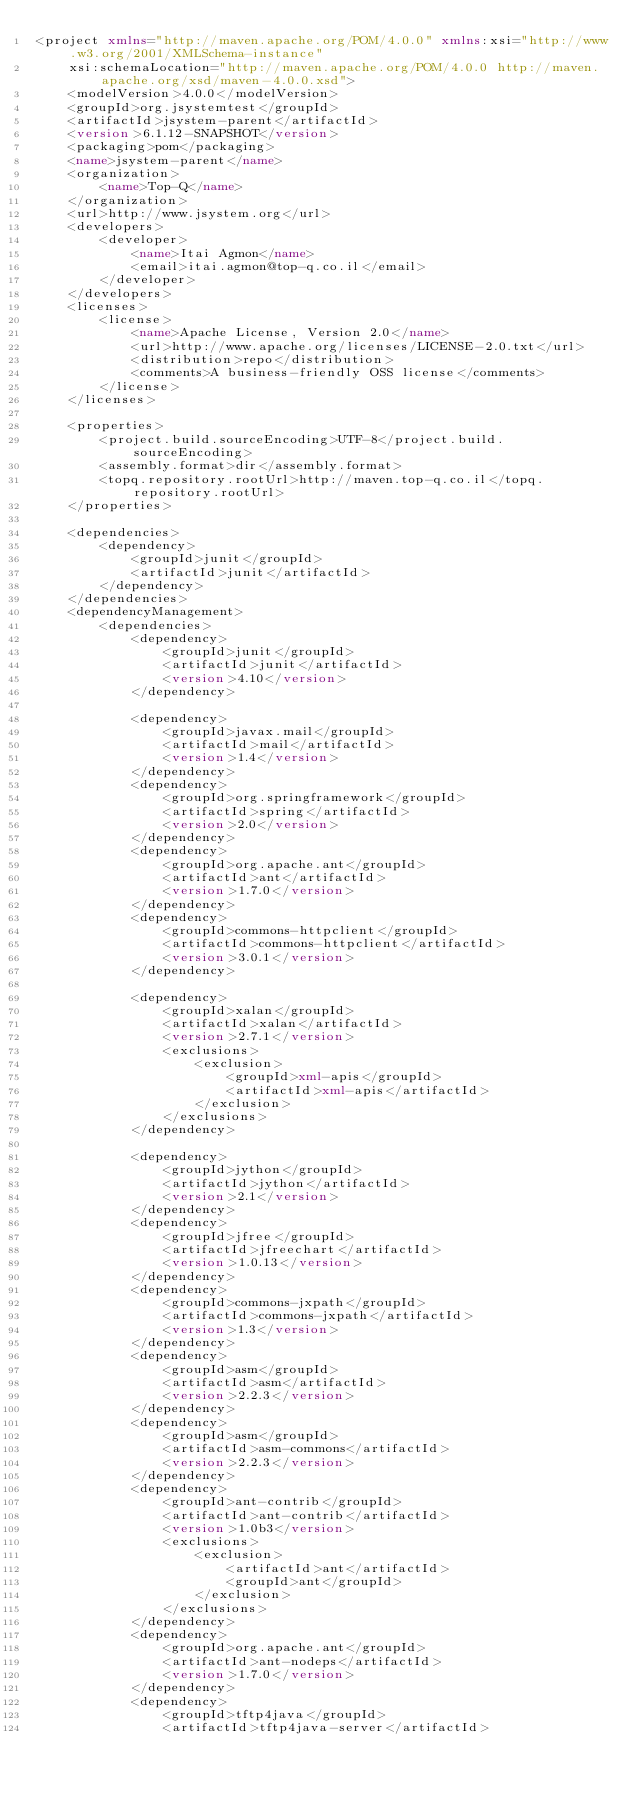Convert code to text. <code><loc_0><loc_0><loc_500><loc_500><_XML_><project xmlns="http://maven.apache.org/POM/4.0.0" xmlns:xsi="http://www.w3.org/2001/XMLSchema-instance"
	xsi:schemaLocation="http://maven.apache.org/POM/4.0.0 http://maven.apache.org/xsd/maven-4.0.0.xsd">
	<modelVersion>4.0.0</modelVersion>
	<groupId>org.jsystemtest</groupId>
	<artifactId>jsystem-parent</artifactId>
	<version>6.1.12-SNAPSHOT</version>
	<packaging>pom</packaging>
	<name>jsystem-parent</name>
	<organization>
		<name>Top-Q</name>
	</organization>
	<url>http://www.jsystem.org</url>
	<developers>
		<developer>
			<name>Itai Agmon</name>
			<email>itai.agmon@top-q.co.il</email>
		</developer>
	</developers>
	<licenses>
		<license>
			<name>Apache License, Version 2.0</name>
			<url>http://www.apache.org/licenses/LICENSE-2.0.txt</url>
			<distribution>repo</distribution>
			<comments>A business-friendly OSS license</comments>
		</license>
	</licenses>

	<properties>
		<project.build.sourceEncoding>UTF-8</project.build.sourceEncoding>
		<assembly.format>dir</assembly.format>
		<topq.repository.rootUrl>http://maven.top-q.co.il</topq.repository.rootUrl>
	</properties>

	<dependencies>
		<dependency>
			<groupId>junit</groupId>
			<artifactId>junit</artifactId>
		</dependency>
	</dependencies>
	<dependencyManagement>
		<dependencies>
			<dependency>
				<groupId>junit</groupId>
				<artifactId>junit</artifactId>
				<version>4.10</version>
			</dependency>

			<dependency>
				<groupId>javax.mail</groupId>
				<artifactId>mail</artifactId>
				<version>1.4</version>
			</dependency>
			<dependency>
				<groupId>org.springframework</groupId>
				<artifactId>spring</artifactId>
				<version>2.0</version>
			</dependency>
			<dependency>
				<groupId>org.apache.ant</groupId>
				<artifactId>ant</artifactId>
				<version>1.7.0</version>
			</dependency>
			<dependency>
				<groupId>commons-httpclient</groupId>
				<artifactId>commons-httpclient</artifactId>
				<version>3.0.1</version>
			</dependency>

			<dependency>
				<groupId>xalan</groupId>
				<artifactId>xalan</artifactId>
				<version>2.7.1</version>
				<exclusions>
					<exclusion>
						<groupId>xml-apis</groupId>
						<artifactId>xml-apis</artifactId>
					</exclusion>
				</exclusions>
			</dependency>

			<dependency>
				<groupId>jython</groupId>
				<artifactId>jython</artifactId>
				<version>2.1</version>
			</dependency>
			<dependency>
				<groupId>jfree</groupId>
				<artifactId>jfreechart</artifactId>
				<version>1.0.13</version>
			</dependency>
			<dependency>
				<groupId>commons-jxpath</groupId>
				<artifactId>commons-jxpath</artifactId>
				<version>1.3</version>
			</dependency>
			<dependency>
				<groupId>asm</groupId>
				<artifactId>asm</artifactId>
				<version>2.2.3</version>
			</dependency>
			<dependency>
				<groupId>asm</groupId>
				<artifactId>asm-commons</artifactId>
				<version>2.2.3</version>
			</dependency>
			<dependency>
				<groupId>ant-contrib</groupId>
				<artifactId>ant-contrib</artifactId>
				<version>1.0b3</version>
				<exclusions>
					<exclusion>
						<artifactId>ant</artifactId>
						<groupId>ant</groupId>
					</exclusion>
				</exclusions>
			</dependency>
			<dependency>
				<groupId>org.apache.ant</groupId>
				<artifactId>ant-nodeps</artifactId>
				<version>1.7.0</version>
			</dependency>
			<dependency>
				<groupId>tftp4java</groupId>
				<artifactId>tftp4java-server</artifactId></code> 